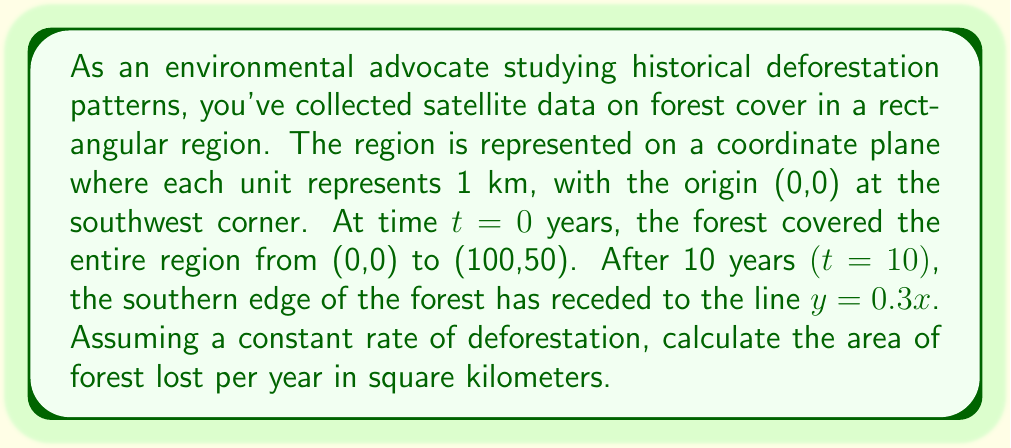Help me with this question. To solve this problem, we'll follow these steps:

1) First, let's calculate the initial forest area at $t=0$:
   $$A_0 = 100 \text{ km} \times 50 \text{ km} = 5000 \text{ km}^2$$

2) Next, we need to calculate the area of the forest at $t=10$. The forest is now bounded by:
   - $x = 0$ (left edge)
   - $x = 100$ (right edge)
   - $y = 50$ (top edge)
   - $y = 0.3x$ (new southern edge)

3) To find this area, we need to integrate:
   $$A_{10} = \int_0^{100} (50 - 0.3x) dx$$
   
   $$= [50x - 0.15x^2]_0^{100}$$
   
   $$= (5000 - 1500) - (0 - 0) = 3500 \text{ km}^2$$

4) The total area lost over 10 years is:
   $$5000 \text{ km}^2 - 3500 \text{ km}^2 = 1500 \text{ km}^2$$

5) Assuming a constant rate of deforestation, we can divide this by 10 to get the annual loss:
   $$\frac{1500 \text{ km}^2}{10 \text{ years}} = 150 \text{ km}^2/\text{year}$$

Therefore, the forest is losing 150 square kilometers per year.
Answer: 150 km²/year 